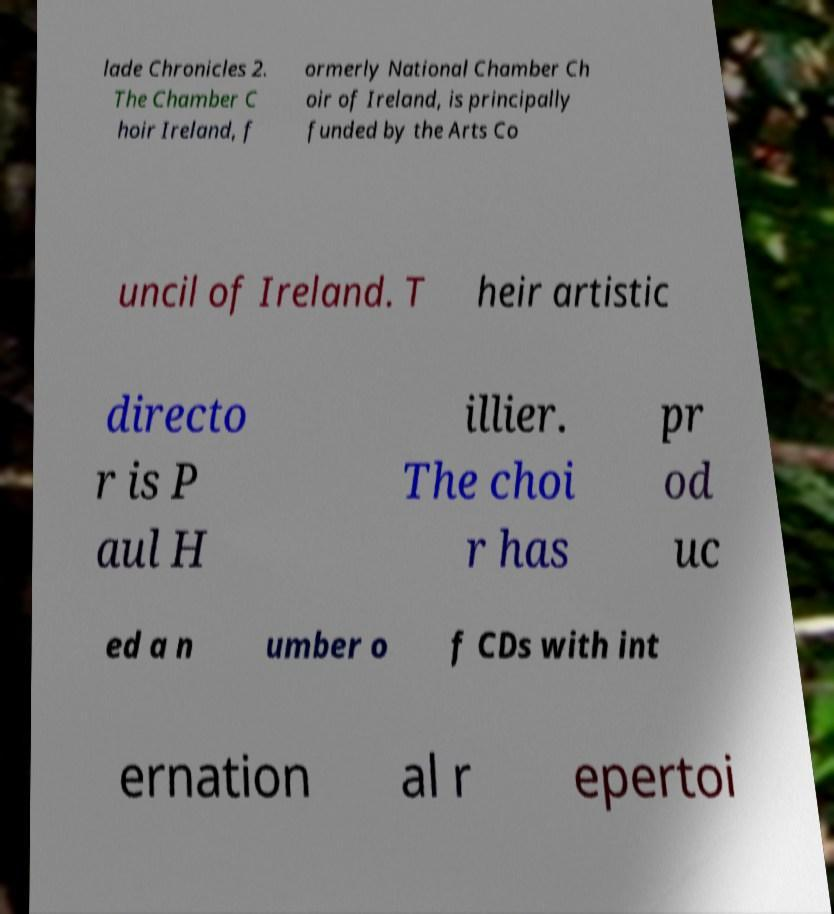For documentation purposes, I need the text within this image transcribed. Could you provide that? lade Chronicles 2. The Chamber C hoir Ireland, f ormerly National Chamber Ch oir of Ireland, is principally funded by the Arts Co uncil of Ireland. T heir artistic directo r is P aul H illier. The choi r has pr od uc ed a n umber o f CDs with int ernation al r epertoi 